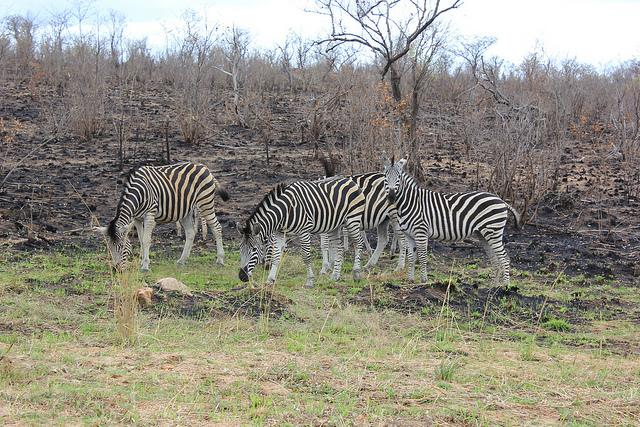What are these animals known for?

Choices:
A) stripes
B) tusks
C) horns
D) antlers stripes 